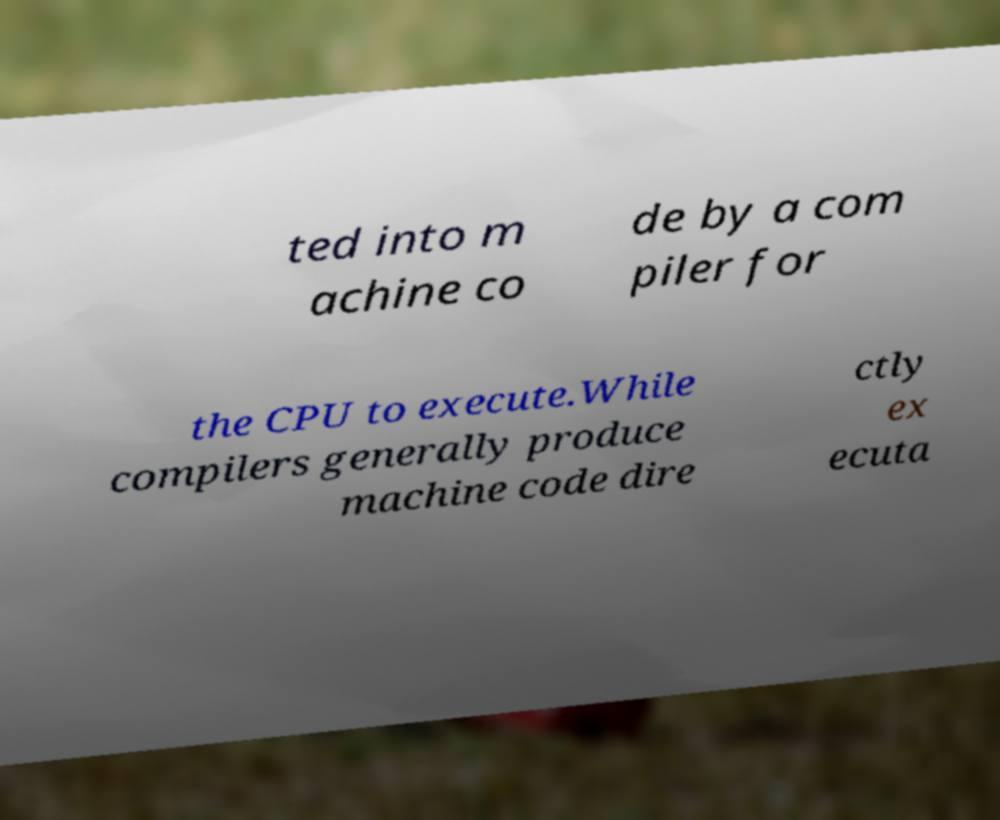Could you assist in decoding the text presented in this image and type it out clearly? ted into m achine co de by a com piler for the CPU to execute.While compilers generally produce machine code dire ctly ex ecuta 